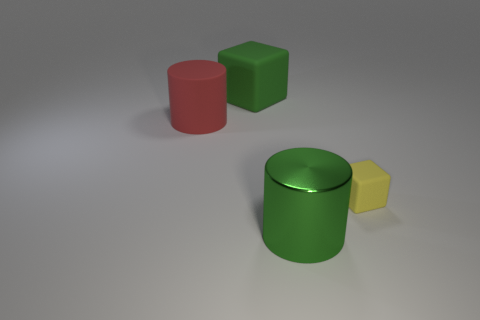What material is the big green object that is the same shape as the large red thing?
Offer a terse response. Metal. Do the small object and the large green matte object have the same shape?
Your response must be concise. Yes. There is a big green matte block; how many big green metal objects are behind it?
Keep it short and to the point. 0. There is a big thing that is on the left side of the big green object that is behind the big red rubber thing; what is its shape?
Provide a short and direct response. Cylinder. There is a big red object that is the same material as the yellow object; what is its shape?
Make the answer very short. Cylinder. Do the green object in front of the green rubber object and the cylinder behind the large green cylinder have the same size?
Give a very brief answer. Yes. There is a big matte thing that is in front of the large cube; what shape is it?
Keep it short and to the point. Cylinder. What color is the small matte thing?
Give a very brief answer. Yellow. Does the metallic cylinder have the same size as the matte block that is in front of the red thing?
Your response must be concise. No. What number of metallic objects are either blue things or small yellow blocks?
Provide a short and direct response. 0. 